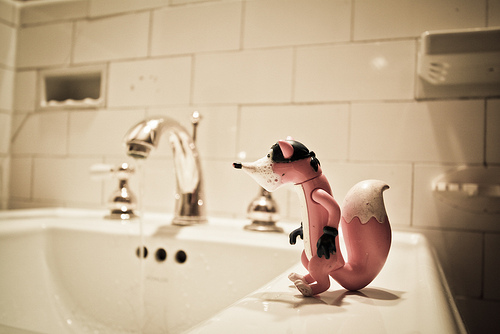<image>
Can you confirm if the toy is on the basin? Yes. Looking at the image, I can see the toy is positioned on top of the basin, with the basin providing support. Is there a figurine to the left of the faucet? No. The figurine is not to the left of the faucet. From this viewpoint, they have a different horizontal relationship. 